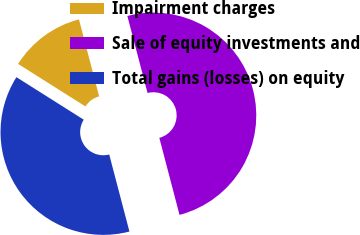Convert chart. <chart><loc_0><loc_0><loc_500><loc_500><pie_chart><fcel>Impairment charges<fcel>Sale of equity investments and<fcel>Total gains (losses) on equity<nl><fcel>11.95%<fcel>50.0%<fcel>38.05%<nl></chart> 